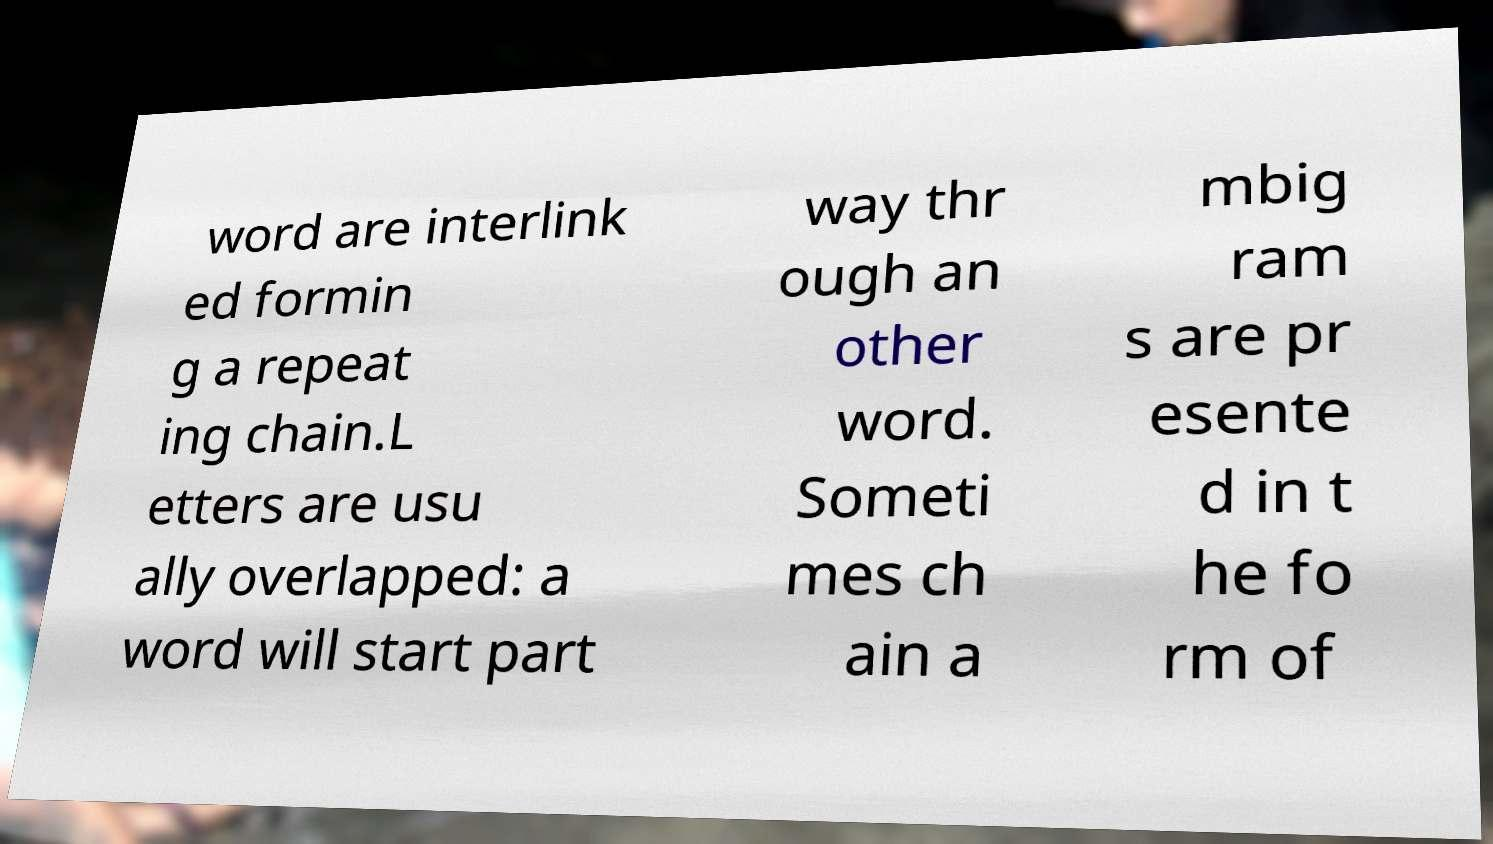I need the written content from this picture converted into text. Can you do that? word are interlink ed formin g a repeat ing chain.L etters are usu ally overlapped: a word will start part way thr ough an other word. Someti mes ch ain a mbig ram s are pr esente d in t he fo rm of 